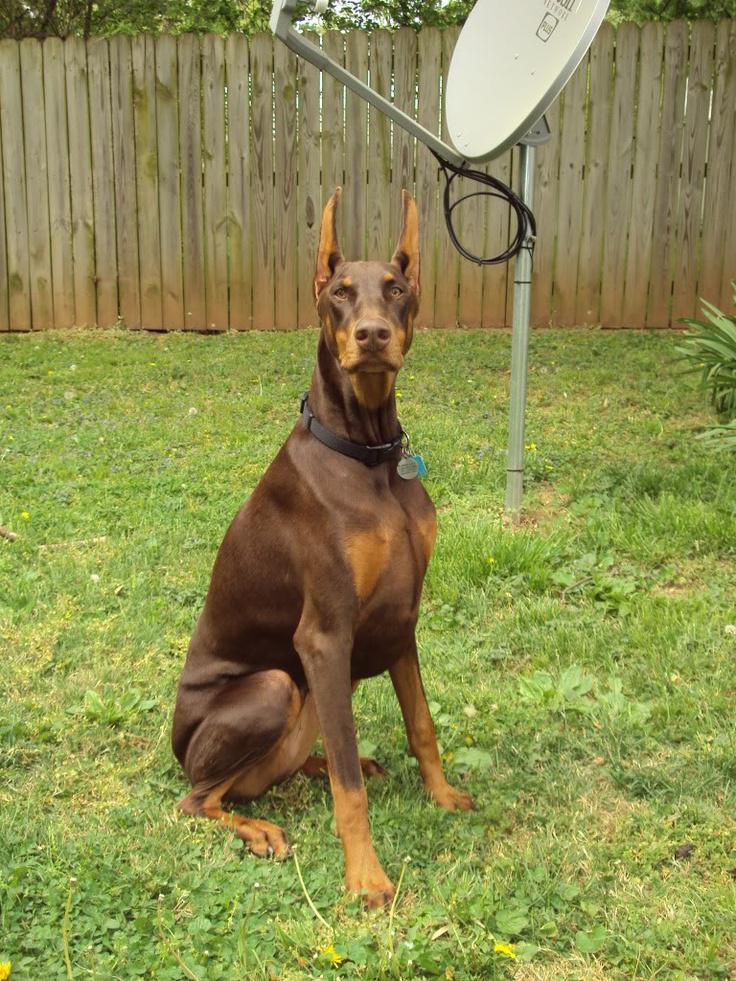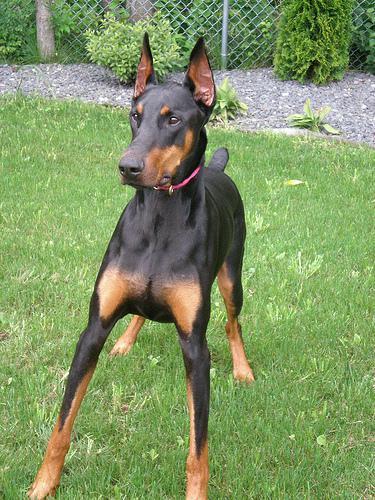The first image is the image on the left, the second image is the image on the right. For the images shown, is this caption "An adult dog is with a puppy." true? Answer yes or no. No. The first image is the image on the left, the second image is the image on the right. For the images shown, is this caption "The dog in the image on the left is situated in the grass." true? Answer yes or no. Yes. 